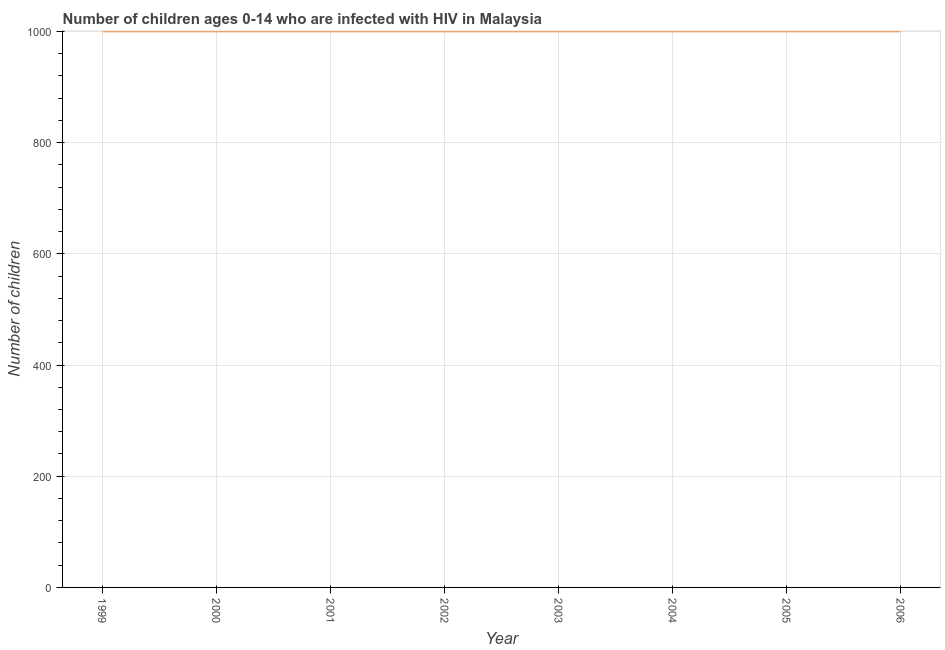What is the number of children living with hiv in 2002?
Your answer should be compact. 1000. Across all years, what is the maximum number of children living with hiv?
Give a very brief answer. 1000. Across all years, what is the minimum number of children living with hiv?
Offer a terse response. 1000. What is the sum of the number of children living with hiv?
Provide a succinct answer. 8000. What is the median number of children living with hiv?
Your answer should be compact. 1000. In how many years, is the number of children living with hiv greater than 80 ?
Make the answer very short. 8. Is the difference between the number of children living with hiv in 1999 and 2006 greater than the difference between any two years?
Your answer should be very brief. Yes. What is the difference between the highest and the second highest number of children living with hiv?
Provide a succinct answer. 0. What is the difference between the highest and the lowest number of children living with hiv?
Offer a very short reply. 0. Does the number of children living with hiv monotonically increase over the years?
Your response must be concise. No. How many lines are there?
Your response must be concise. 1. How many years are there in the graph?
Give a very brief answer. 8. What is the difference between two consecutive major ticks on the Y-axis?
Your answer should be very brief. 200. Are the values on the major ticks of Y-axis written in scientific E-notation?
Provide a short and direct response. No. Does the graph contain grids?
Make the answer very short. Yes. What is the title of the graph?
Your answer should be compact. Number of children ages 0-14 who are infected with HIV in Malaysia. What is the label or title of the X-axis?
Provide a succinct answer. Year. What is the label or title of the Y-axis?
Your answer should be very brief. Number of children. What is the Number of children in 1999?
Your answer should be very brief. 1000. What is the Number of children in 2000?
Your answer should be compact. 1000. What is the Number of children of 2003?
Make the answer very short. 1000. What is the Number of children in 2005?
Ensure brevity in your answer.  1000. What is the Number of children in 2006?
Ensure brevity in your answer.  1000. What is the difference between the Number of children in 1999 and 2002?
Give a very brief answer. 0. What is the difference between the Number of children in 2000 and 2002?
Your answer should be very brief. 0. What is the difference between the Number of children in 2000 and 2003?
Make the answer very short. 0. What is the difference between the Number of children in 2000 and 2005?
Give a very brief answer. 0. What is the difference between the Number of children in 2001 and 2003?
Your answer should be compact. 0. What is the difference between the Number of children in 2001 and 2006?
Your response must be concise. 0. What is the difference between the Number of children in 2002 and 2004?
Ensure brevity in your answer.  0. What is the difference between the Number of children in 2002 and 2006?
Offer a very short reply. 0. What is the difference between the Number of children in 2003 and 2004?
Keep it short and to the point. 0. What is the difference between the Number of children in 2003 and 2006?
Ensure brevity in your answer.  0. What is the difference between the Number of children in 2005 and 2006?
Provide a succinct answer. 0. What is the ratio of the Number of children in 1999 to that in 2003?
Give a very brief answer. 1. What is the ratio of the Number of children in 1999 to that in 2004?
Offer a very short reply. 1. What is the ratio of the Number of children in 1999 to that in 2006?
Provide a short and direct response. 1. What is the ratio of the Number of children in 2000 to that in 2001?
Your response must be concise. 1. What is the ratio of the Number of children in 2000 to that in 2002?
Provide a succinct answer. 1. What is the ratio of the Number of children in 2000 to that in 2003?
Offer a very short reply. 1. What is the ratio of the Number of children in 2000 to that in 2005?
Provide a succinct answer. 1. What is the ratio of the Number of children in 2000 to that in 2006?
Your response must be concise. 1. What is the ratio of the Number of children in 2001 to that in 2002?
Your answer should be compact. 1. What is the ratio of the Number of children in 2001 to that in 2004?
Make the answer very short. 1. What is the ratio of the Number of children in 2002 to that in 2006?
Ensure brevity in your answer.  1. What is the ratio of the Number of children in 2003 to that in 2004?
Your answer should be very brief. 1. What is the ratio of the Number of children in 2003 to that in 2006?
Offer a very short reply. 1. 